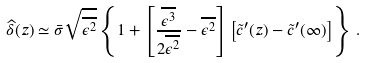<formula> <loc_0><loc_0><loc_500><loc_500>\widehat { \delta } ( z ) \simeq \bar { \sigma } \sqrt { \overline { \epsilon ^ { 2 } } } \left \{ 1 + \left [ \frac { \overline { \epsilon ^ { 3 } } } { 2 \overline { \epsilon ^ { 2 } } } - \overline { \epsilon ^ { 2 } } \right ] \left [ \tilde { c } ^ { \prime } ( z ) - \tilde { c } ^ { \prime } ( \infty ) \right ] \right \} \, .</formula> 